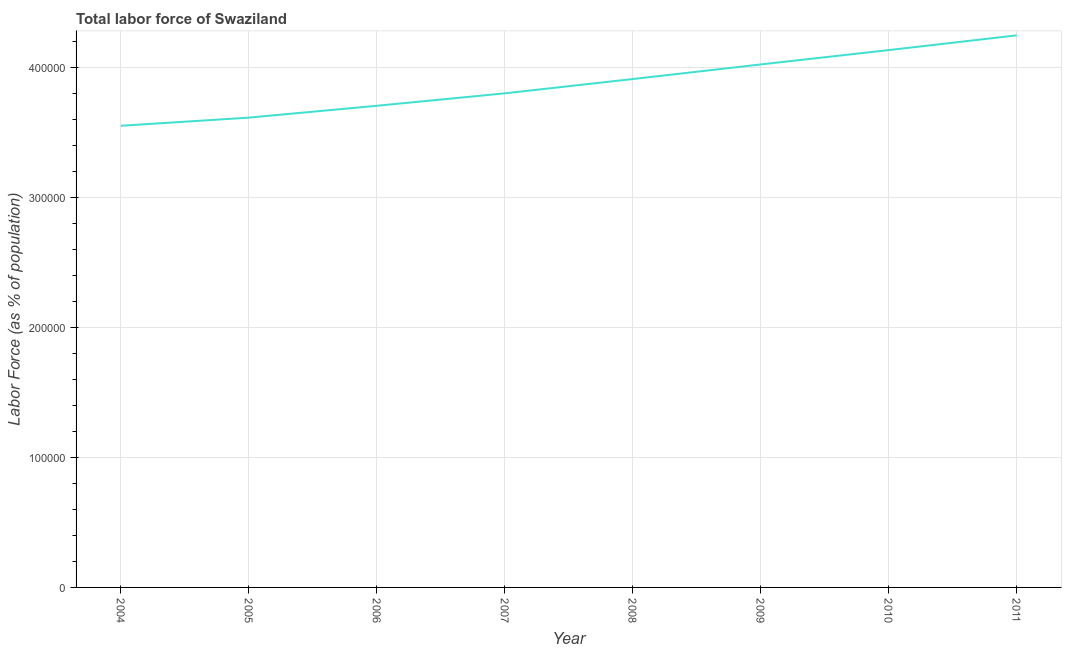What is the total labor force in 2009?
Your answer should be very brief. 4.02e+05. Across all years, what is the maximum total labor force?
Keep it short and to the point. 4.24e+05. Across all years, what is the minimum total labor force?
Your response must be concise. 3.55e+05. In which year was the total labor force minimum?
Provide a short and direct response. 2004. What is the sum of the total labor force?
Provide a short and direct response. 3.10e+06. What is the difference between the total labor force in 2006 and 2010?
Give a very brief answer. -4.28e+04. What is the average total labor force per year?
Your response must be concise. 3.87e+05. What is the median total labor force?
Your answer should be compact. 3.85e+05. In how many years, is the total labor force greater than 180000 %?
Your answer should be compact. 8. What is the ratio of the total labor force in 2008 to that in 2009?
Offer a terse response. 0.97. Is the total labor force in 2005 less than that in 2007?
Make the answer very short. Yes. What is the difference between the highest and the second highest total labor force?
Offer a terse response. 1.13e+04. What is the difference between the highest and the lowest total labor force?
Offer a very short reply. 6.95e+04. What is the difference between two consecutive major ticks on the Y-axis?
Offer a terse response. 1.00e+05. Does the graph contain any zero values?
Offer a terse response. No. Does the graph contain grids?
Provide a succinct answer. Yes. What is the title of the graph?
Your response must be concise. Total labor force of Swaziland. What is the label or title of the X-axis?
Ensure brevity in your answer.  Year. What is the label or title of the Y-axis?
Keep it short and to the point. Labor Force (as % of population). What is the Labor Force (as % of population) in 2004?
Offer a terse response. 3.55e+05. What is the Labor Force (as % of population) in 2005?
Give a very brief answer. 3.61e+05. What is the Labor Force (as % of population) of 2006?
Offer a terse response. 3.70e+05. What is the Labor Force (as % of population) of 2007?
Provide a succinct answer. 3.80e+05. What is the Labor Force (as % of population) in 2008?
Ensure brevity in your answer.  3.91e+05. What is the Labor Force (as % of population) of 2009?
Give a very brief answer. 4.02e+05. What is the Labor Force (as % of population) in 2010?
Provide a succinct answer. 4.13e+05. What is the Labor Force (as % of population) in 2011?
Your answer should be very brief. 4.24e+05. What is the difference between the Labor Force (as % of population) in 2004 and 2005?
Give a very brief answer. -6265. What is the difference between the Labor Force (as % of population) in 2004 and 2006?
Ensure brevity in your answer.  -1.54e+04. What is the difference between the Labor Force (as % of population) in 2004 and 2007?
Make the answer very short. -2.49e+04. What is the difference between the Labor Force (as % of population) in 2004 and 2008?
Provide a succinct answer. -3.59e+04. What is the difference between the Labor Force (as % of population) in 2004 and 2009?
Give a very brief answer. -4.72e+04. What is the difference between the Labor Force (as % of population) in 2004 and 2010?
Offer a very short reply. -5.82e+04. What is the difference between the Labor Force (as % of population) in 2004 and 2011?
Offer a terse response. -6.95e+04. What is the difference between the Labor Force (as % of population) in 2005 and 2006?
Provide a short and direct response. -9107. What is the difference between the Labor Force (as % of population) in 2005 and 2007?
Your answer should be very brief. -1.87e+04. What is the difference between the Labor Force (as % of population) in 2005 and 2008?
Make the answer very short. -2.97e+04. What is the difference between the Labor Force (as % of population) in 2005 and 2009?
Make the answer very short. -4.09e+04. What is the difference between the Labor Force (as % of population) in 2005 and 2010?
Offer a very short reply. -5.19e+04. What is the difference between the Labor Force (as % of population) in 2005 and 2011?
Make the answer very short. -6.32e+04. What is the difference between the Labor Force (as % of population) in 2006 and 2007?
Give a very brief answer. -9557. What is the difference between the Labor Force (as % of population) in 2006 and 2008?
Provide a succinct answer. -2.05e+04. What is the difference between the Labor Force (as % of population) in 2006 and 2009?
Your answer should be compact. -3.18e+04. What is the difference between the Labor Force (as % of population) in 2006 and 2010?
Offer a very short reply. -4.28e+04. What is the difference between the Labor Force (as % of population) in 2006 and 2011?
Your response must be concise. -5.41e+04. What is the difference between the Labor Force (as % of population) in 2007 and 2008?
Provide a succinct answer. -1.10e+04. What is the difference between the Labor Force (as % of population) in 2007 and 2009?
Keep it short and to the point. -2.22e+04. What is the difference between the Labor Force (as % of population) in 2007 and 2010?
Provide a succinct answer. -3.32e+04. What is the difference between the Labor Force (as % of population) in 2007 and 2011?
Your answer should be very brief. -4.46e+04. What is the difference between the Labor Force (as % of population) in 2008 and 2009?
Offer a very short reply. -1.12e+04. What is the difference between the Labor Force (as % of population) in 2008 and 2010?
Keep it short and to the point. -2.23e+04. What is the difference between the Labor Force (as % of population) in 2008 and 2011?
Your response must be concise. -3.36e+04. What is the difference between the Labor Force (as % of population) in 2009 and 2010?
Your answer should be compact. -1.10e+04. What is the difference between the Labor Force (as % of population) in 2009 and 2011?
Ensure brevity in your answer.  -2.24e+04. What is the difference between the Labor Force (as % of population) in 2010 and 2011?
Provide a succinct answer. -1.13e+04. What is the ratio of the Labor Force (as % of population) in 2004 to that in 2006?
Give a very brief answer. 0.96. What is the ratio of the Labor Force (as % of population) in 2004 to that in 2007?
Offer a very short reply. 0.93. What is the ratio of the Labor Force (as % of population) in 2004 to that in 2008?
Offer a very short reply. 0.91. What is the ratio of the Labor Force (as % of population) in 2004 to that in 2009?
Your answer should be compact. 0.88. What is the ratio of the Labor Force (as % of population) in 2004 to that in 2010?
Your answer should be very brief. 0.86. What is the ratio of the Labor Force (as % of population) in 2004 to that in 2011?
Your response must be concise. 0.84. What is the ratio of the Labor Force (as % of population) in 2005 to that in 2007?
Offer a terse response. 0.95. What is the ratio of the Labor Force (as % of population) in 2005 to that in 2008?
Provide a succinct answer. 0.92. What is the ratio of the Labor Force (as % of population) in 2005 to that in 2009?
Offer a terse response. 0.9. What is the ratio of the Labor Force (as % of population) in 2005 to that in 2010?
Ensure brevity in your answer.  0.87. What is the ratio of the Labor Force (as % of population) in 2005 to that in 2011?
Offer a very short reply. 0.85. What is the ratio of the Labor Force (as % of population) in 2006 to that in 2008?
Offer a terse response. 0.95. What is the ratio of the Labor Force (as % of population) in 2006 to that in 2009?
Provide a short and direct response. 0.92. What is the ratio of the Labor Force (as % of population) in 2006 to that in 2010?
Ensure brevity in your answer.  0.9. What is the ratio of the Labor Force (as % of population) in 2006 to that in 2011?
Your response must be concise. 0.87. What is the ratio of the Labor Force (as % of population) in 2007 to that in 2008?
Keep it short and to the point. 0.97. What is the ratio of the Labor Force (as % of population) in 2007 to that in 2009?
Make the answer very short. 0.94. What is the ratio of the Labor Force (as % of population) in 2007 to that in 2010?
Make the answer very short. 0.92. What is the ratio of the Labor Force (as % of population) in 2007 to that in 2011?
Your answer should be very brief. 0.9. What is the ratio of the Labor Force (as % of population) in 2008 to that in 2009?
Make the answer very short. 0.97. What is the ratio of the Labor Force (as % of population) in 2008 to that in 2010?
Ensure brevity in your answer.  0.95. What is the ratio of the Labor Force (as % of population) in 2008 to that in 2011?
Offer a terse response. 0.92. What is the ratio of the Labor Force (as % of population) in 2009 to that in 2010?
Offer a very short reply. 0.97. What is the ratio of the Labor Force (as % of population) in 2009 to that in 2011?
Give a very brief answer. 0.95. What is the ratio of the Labor Force (as % of population) in 2010 to that in 2011?
Give a very brief answer. 0.97. 